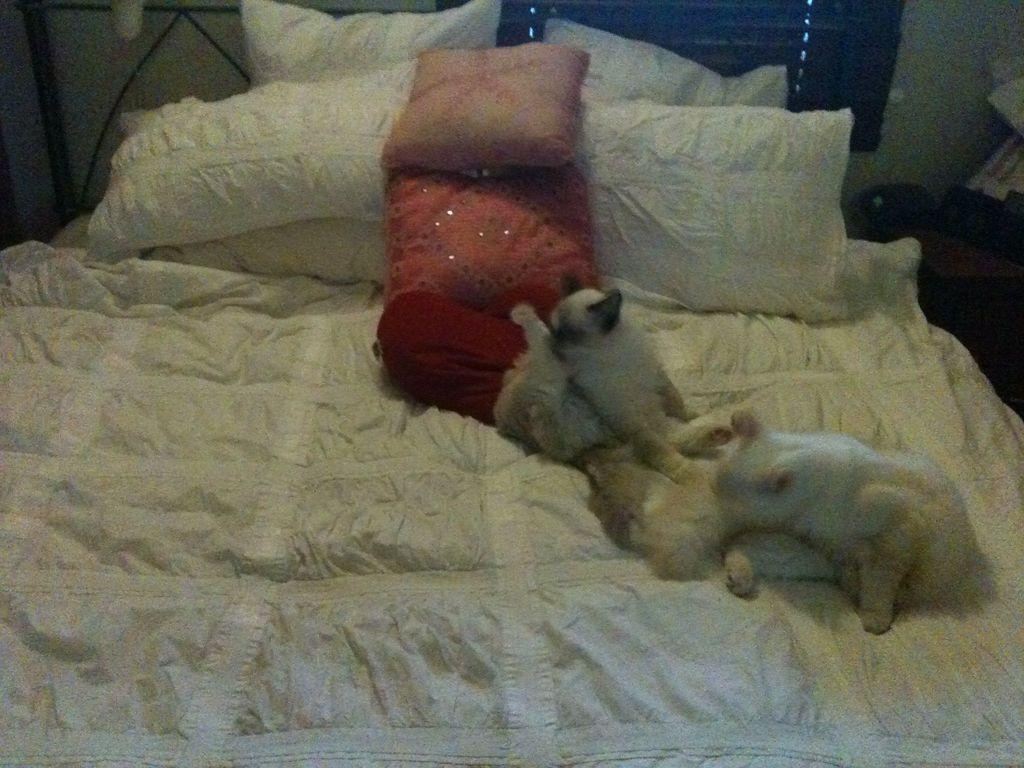What types of living organisms are in the image? There are animals in the image. Where are the animals located? The animals are on a bed. What else can be seen on the bed? There are pillows on the bed. What can be seen in the background of the image? There is a window and a wall in the background of the image, along with some objects. What type of trade is being conducted by the animals in the image? There is no trade being conducted in the image; it features animals on a bed with pillows. Can you tell me how many clams are visible in the image? There are no clams present in the image; it features animals on a bed with pillows. 